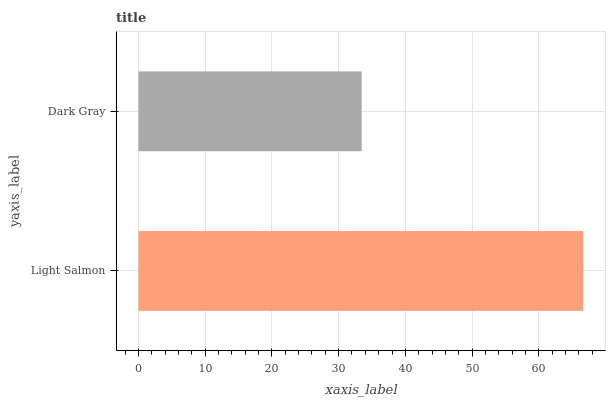Is Dark Gray the minimum?
Answer yes or no. Yes. Is Light Salmon the maximum?
Answer yes or no. Yes. Is Dark Gray the maximum?
Answer yes or no. No. Is Light Salmon greater than Dark Gray?
Answer yes or no. Yes. Is Dark Gray less than Light Salmon?
Answer yes or no. Yes. Is Dark Gray greater than Light Salmon?
Answer yes or no. No. Is Light Salmon less than Dark Gray?
Answer yes or no. No. Is Light Salmon the high median?
Answer yes or no. Yes. Is Dark Gray the low median?
Answer yes or no. Yes. Is Dark Gray the high median?
Answer yes or no. No. Is Light Salmon the low median?
Answer yes or no. No. 